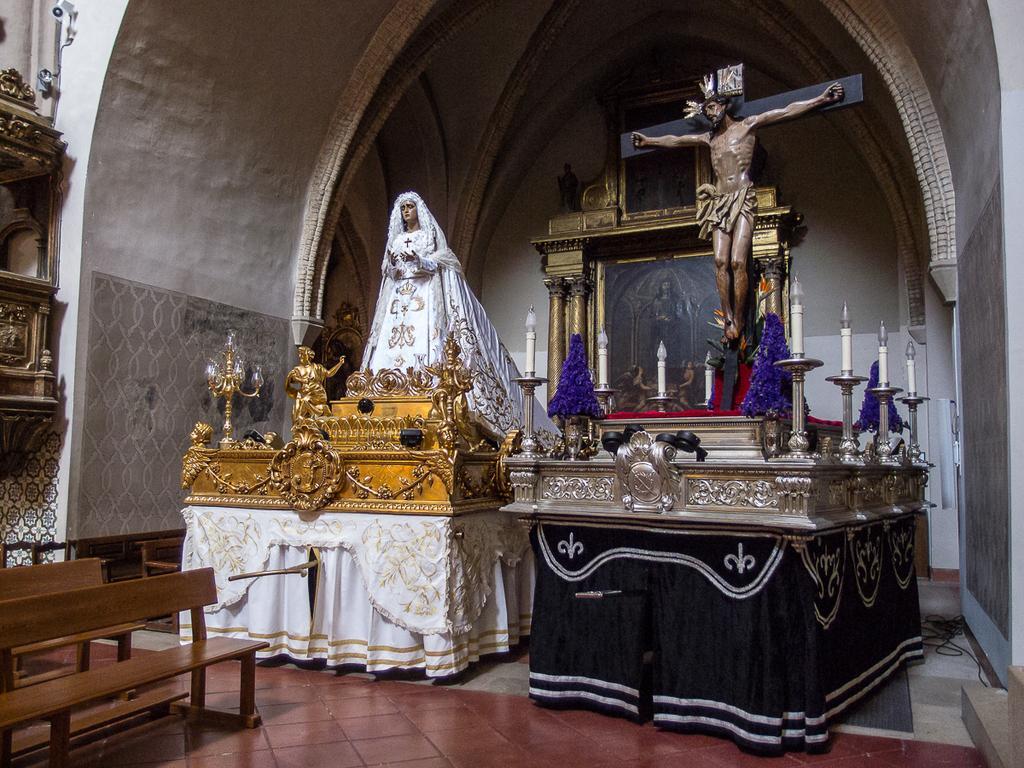How would you summarize this image in a sentence or two? In this picture I can see benches, there are sculptures, clothes, those are looking like flower vases, those are looking like candles with the candles stands, and there are some other objects. 